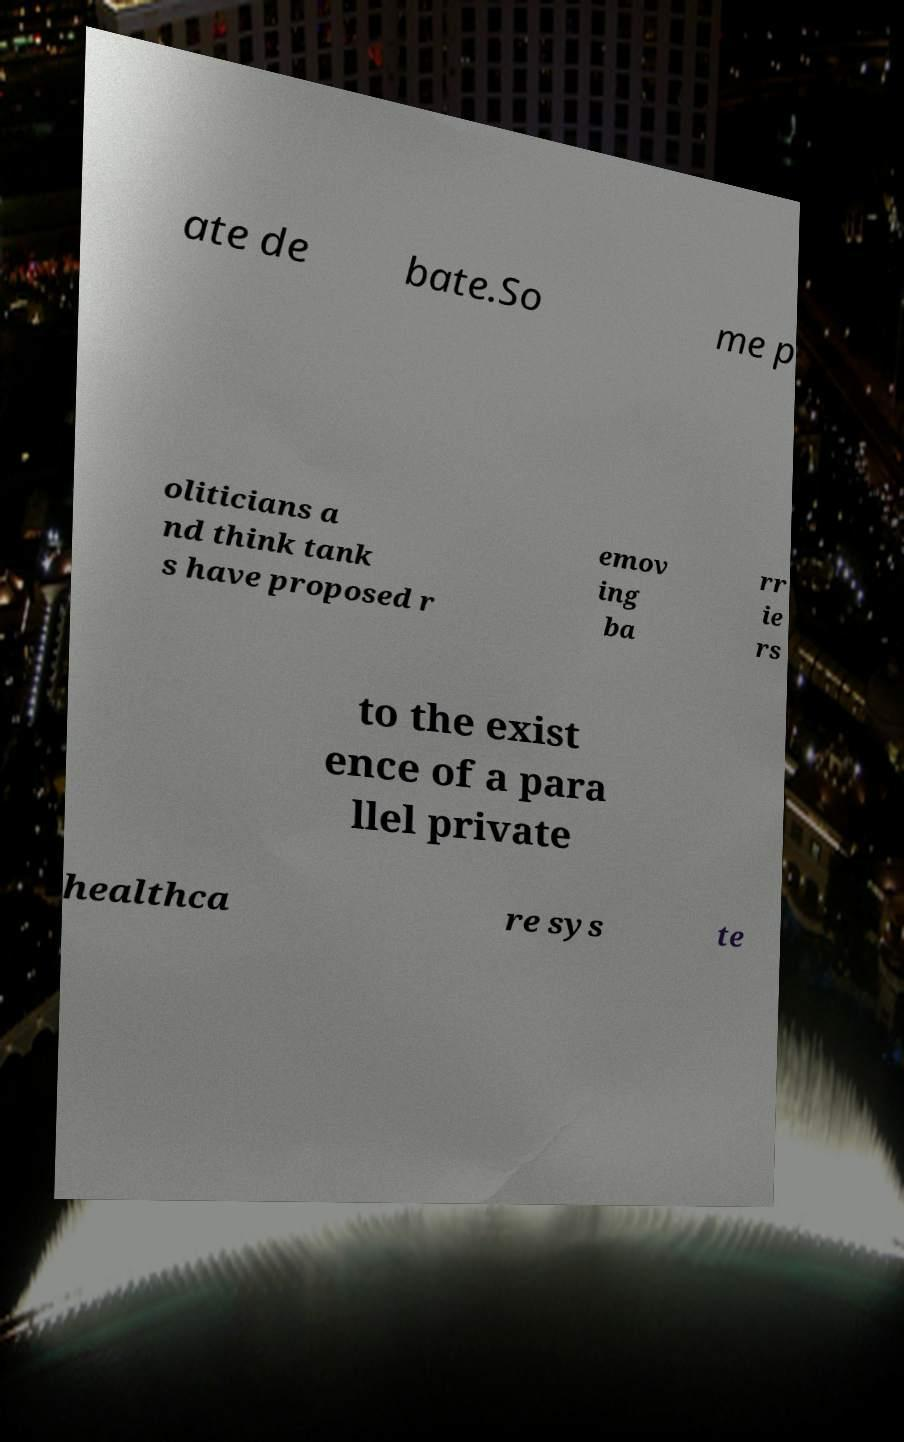Please identify and transcribe the text found in this image. ate de bate.So me p oliticians a nd think tank s have proposed r emov ing ba rr ie rs to the exist ence of a para llel private healthca re sys te 